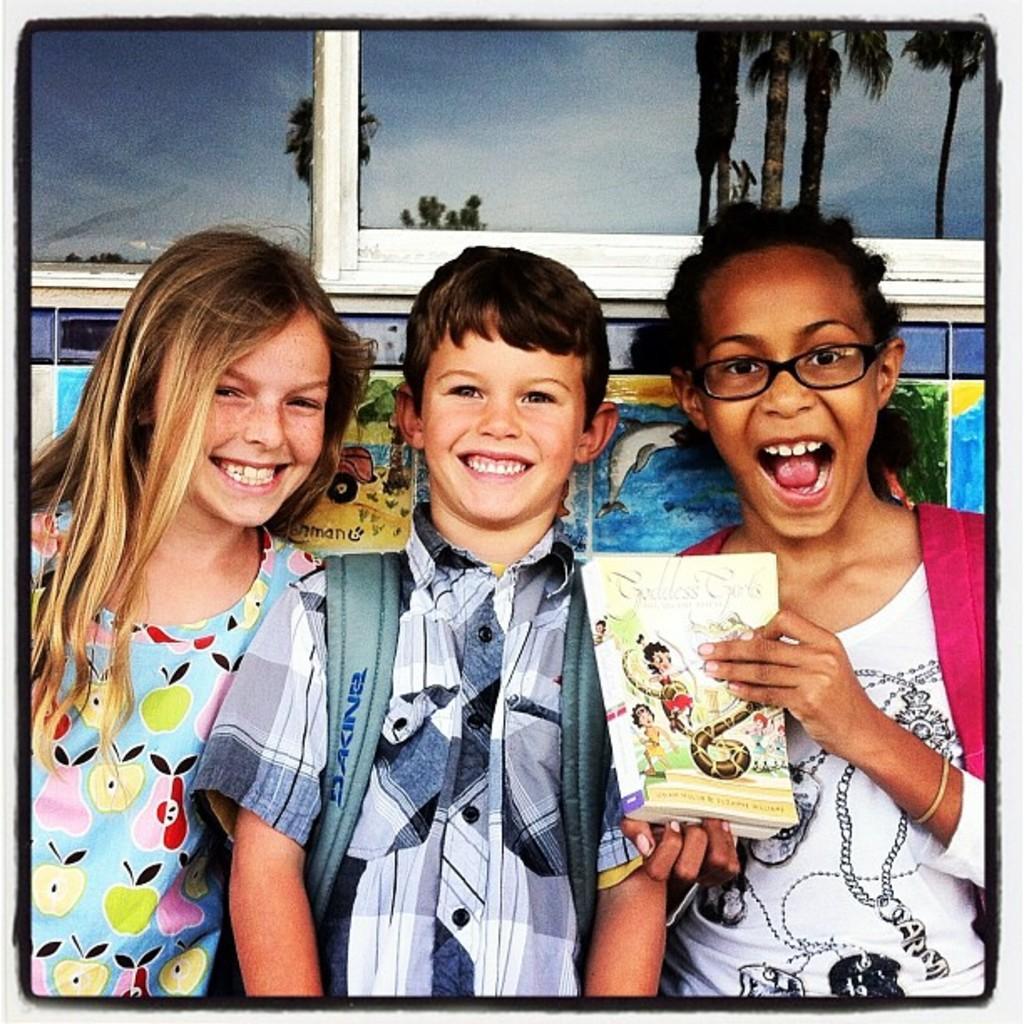Please provide a concise description of this image. In the middle a boy is standing, he wore a shirt. On the right side a girl is smiling and also holding a book in her hands. On the left side a girl is also smiling, she wore blue color t-shirt. 